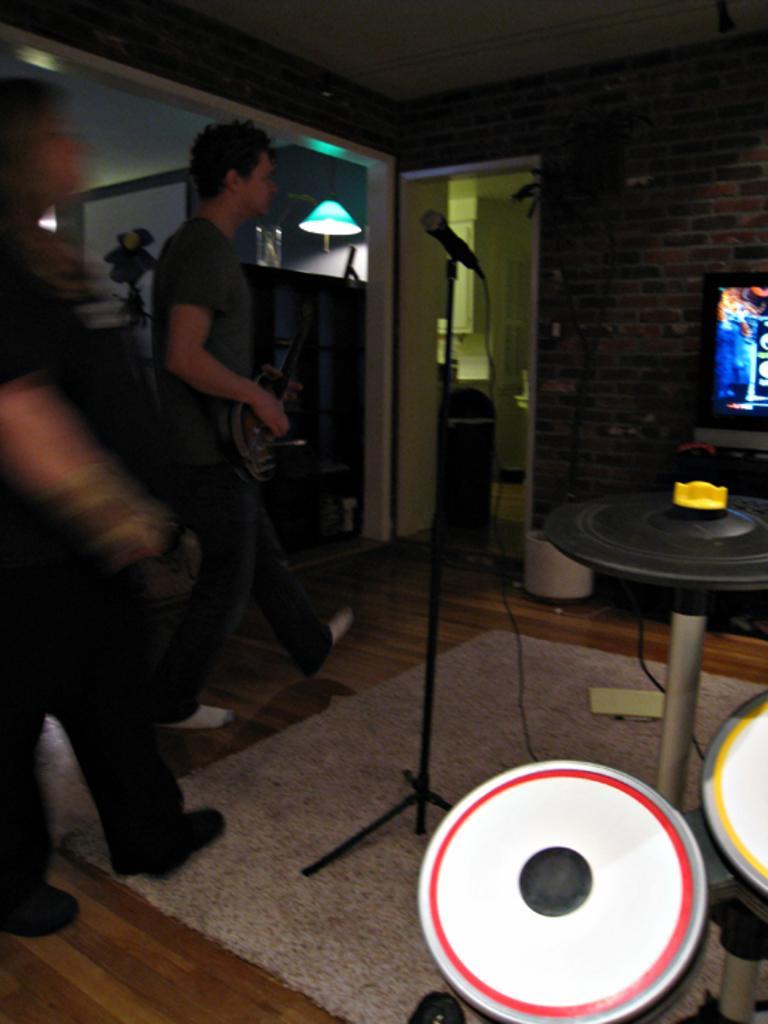How would you summarize this image in a sentence or two? In the image we can see mic, persons, wall, door, television, musical instruments, table and light. 